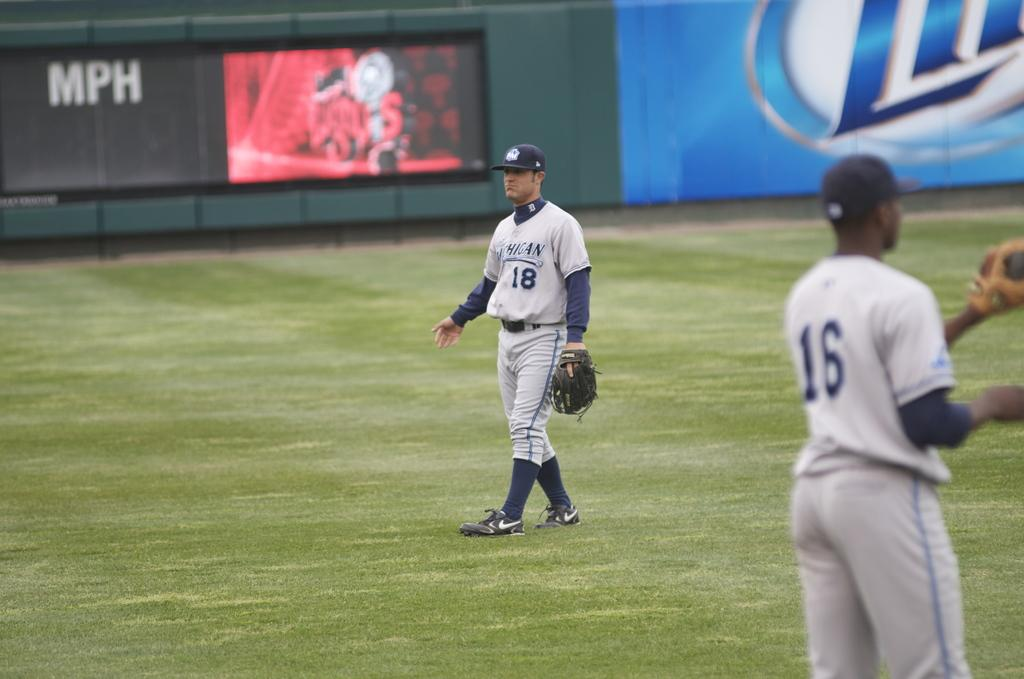<image>
Describe the image concisely. Baseball player wearing the jersey number 18 walking on grass. 